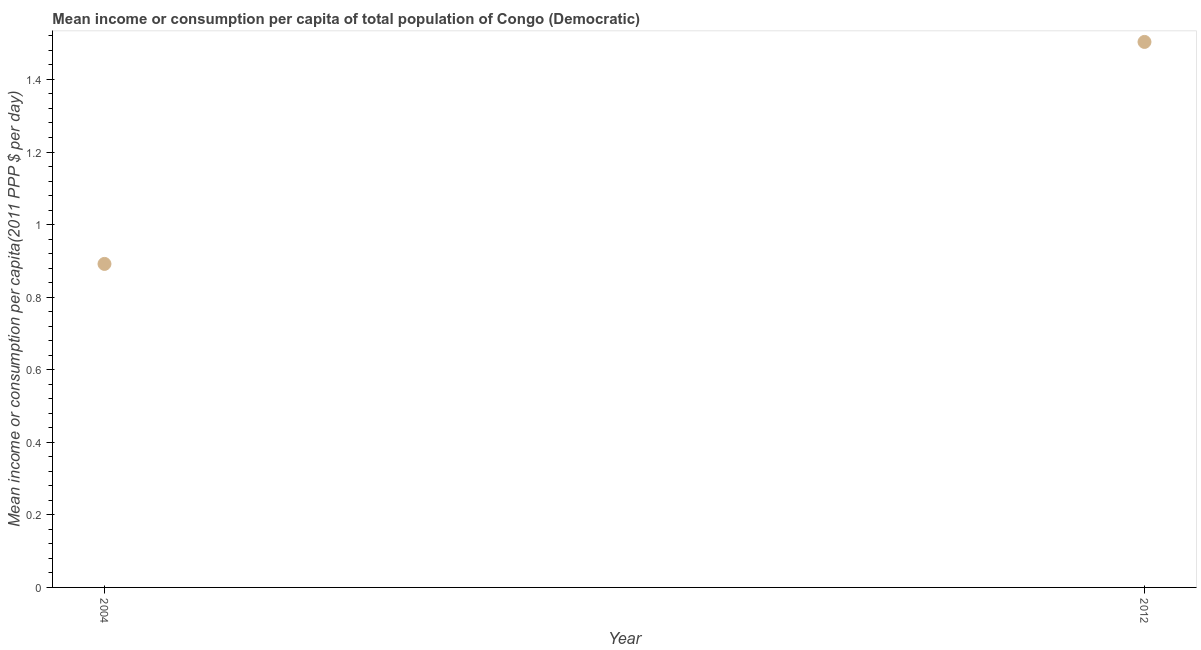What is the mean income or consumption in 2012?
Give a very brief answer. 1.5. Across all years, what is the maximum mean income or consumption?
Make the answer very short. 1.5. Across all years, what is the minimum mean income or consumption?
Offer a terse response. 0.89. In which year was the mean income or consumption maximum?
Keep it short and to the point. 2012. What is the sum of the mean income or consumption?
Provide a succinct answer. 2.39. What is the difference between the mean income or consumption in 2004 and 2012?
Keep it short and to the point. -0.61. What is the average mean income or consumption per year?
Make the answer very short. 1.2. What is the median mean income or consumption?
Your answer should be very brief. 1.2. In how many years, is the mean income or consumption greater than 0.48000000000000004 $?
Make the answer very short. 2. Do a majority of the years between 2004 and 2012 (inclusive) have mean income or consumption greater than 0.88 $?
Your answer should be compact. Yes. What is the ratio of the mean income or consumption in 2004 to that in 2012?
Provide a short and direct response. 0.59. In how many years, is the mean income or consumption greater than the average mean income or consumption taken over all years?
Keep it short and to the point. 1. Does the mean income or consumption monotonically increase over the years?
Your response must be concise. Yes. How many dotlines are there?
Make the answer very short. 1. Does the graph contain any zero values?
Keep it short and to the point. No. Does the graph contain grids?
Provide a succinct answer. No. What is the title of the graph?
Provide a succinct answer. Mean income or consumption per capita of total population of Congo (Democratic). What is the label or title of the Y-axis?
Ensure brevity in your answer.  Mean income or consumption per capita(2011 PPP $ per day). What is the Mean income or consumption per capita(2011 PPP $ per day) in 2004?
Your response must be concise. 0.89. What is the Mean income or consumption per capita(2011 PPP $ per day) in 2012?
Offer a very short reply. 1.5. What is the difference between the Mean income or consumption per capita(2011 PPP $ per day) in 2004 and 2012?
Provide a succinct answer. -0.61. What is the ratio of the Mean income or consumption per capita(2011 PPP $ per day) in 2004 to that in 2012?
Provide a succinct answer. 0.59. 